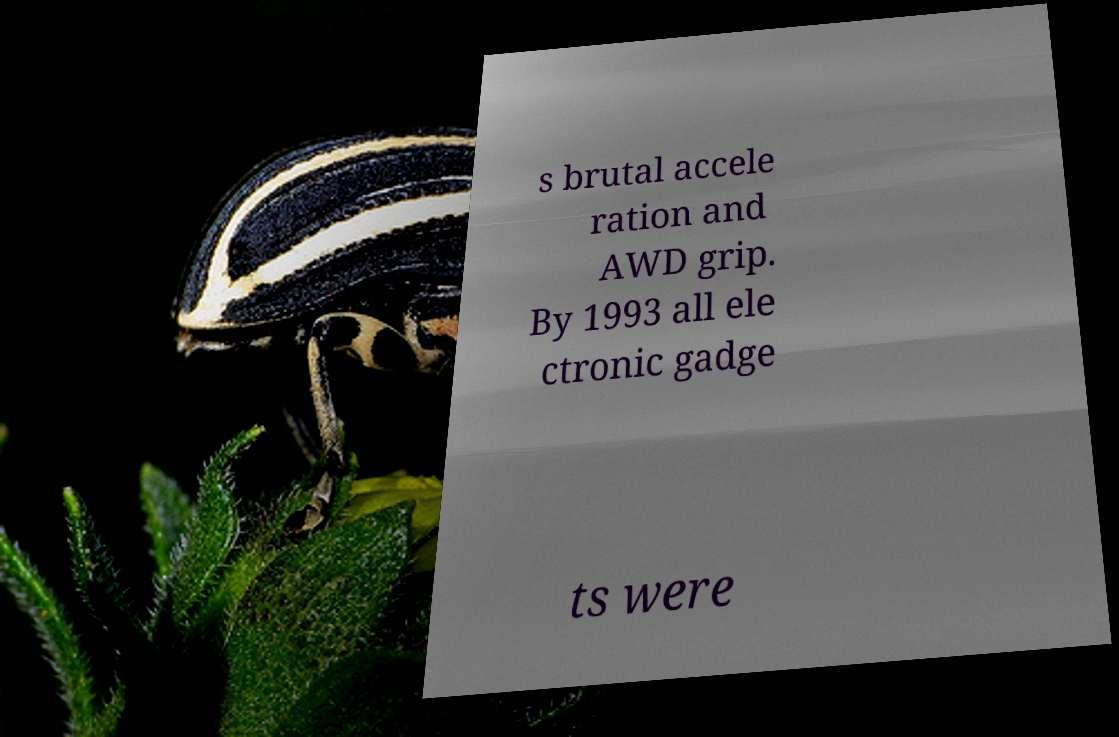I need the written content from this picture converted into text. Can you do that? s brutal accele ration and AWD grip. By 1993 all ele ctronic gadge ts were 